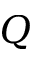Convert formula to latex. <formula><loc_0><loc_0><loc_500><loc_500>Q</formula> 